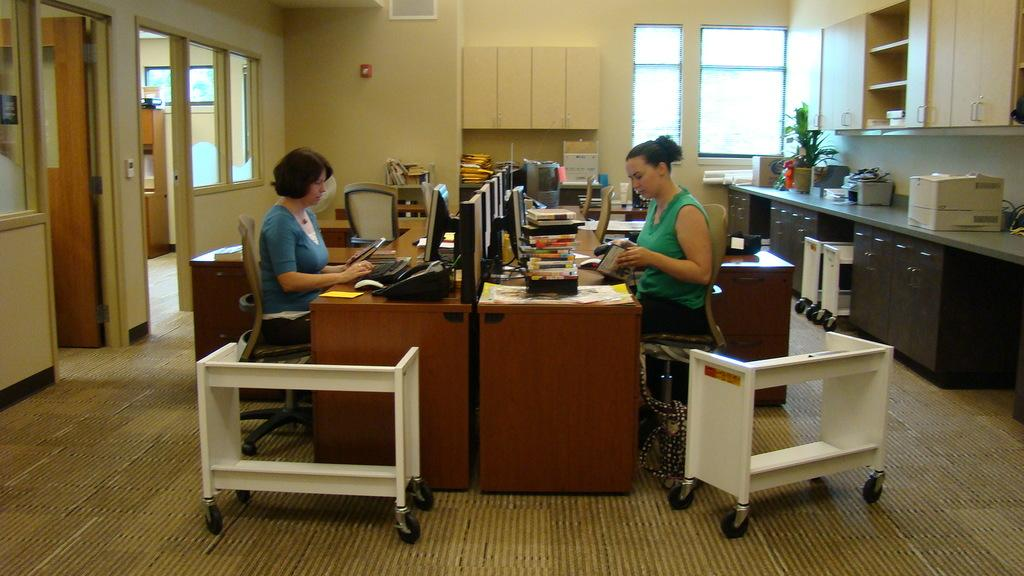How many women are in the image? There are two women in the image. What are the women doing in the image? The women are sitting on chairs. Are the women facing the same direction or different directions? The women are facing opposite directions. What type of drink is being twisted by one of the women in the image? There is no drink or twisting action present in the image; the women are simply sitting on chairs facing opposite directions. 